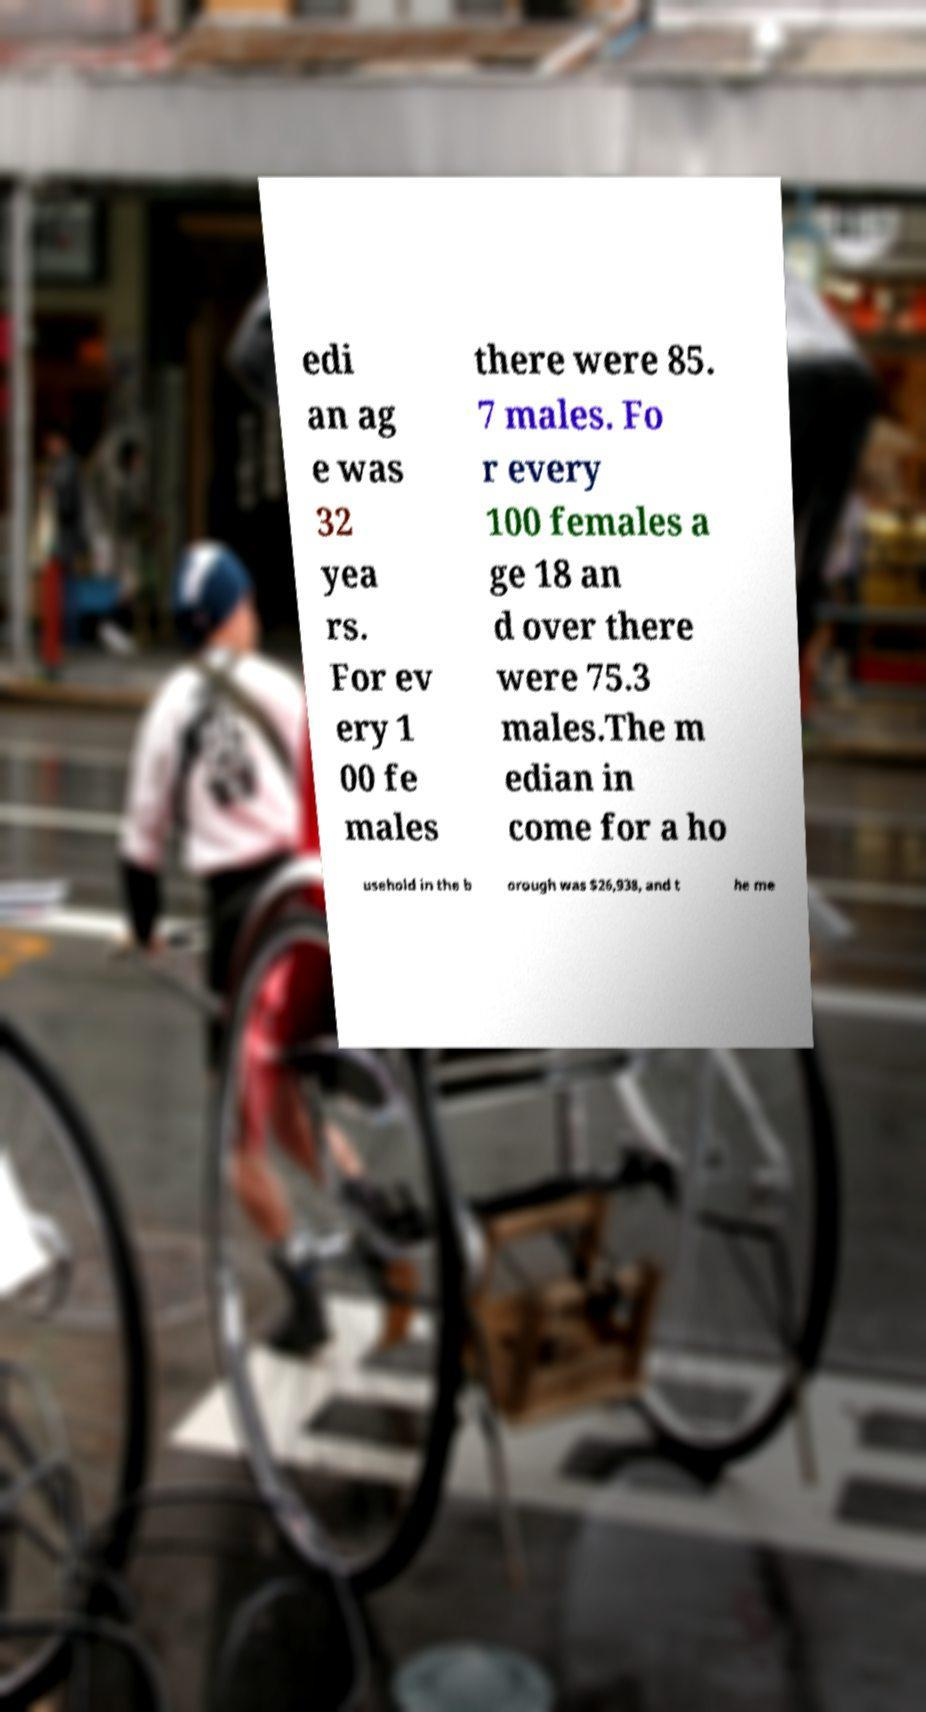Can you read and provide the text displayed in the image?This photo seems to have some interesting text. Can you extract and type it out for me? edi an ag e was 32 yea rs. For ev ery 1 00 fe males there were 85. 7 males. Fo r every 100 females a ge 18 an d over there were 75.3 males.The m edian in come for a ho usehold in the b orough was $26,938, and t he me 